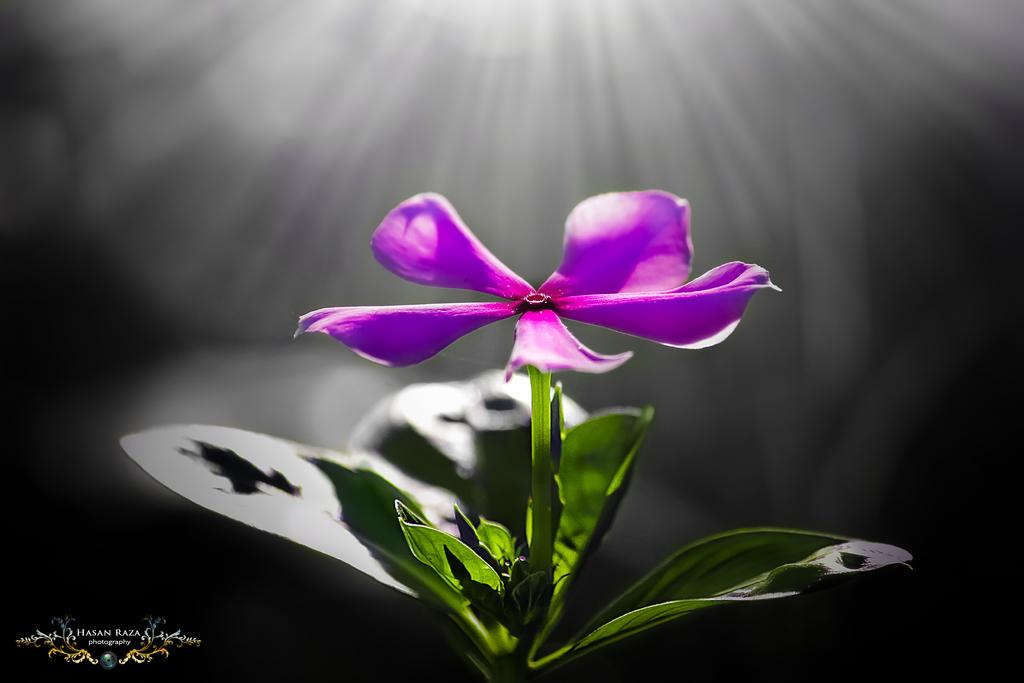What is the main subject of the image? The main subject of the image is a flower. Can you describe the flower's location in the image? The flower is on the stem of a plant. How many horses are visible in the image? There are no horses present in the image; it features a flower on the stem of a plant. What type of watch is being worn by the flower in the image? There is no watch present in the image, as it features a flower on the stem of a plant. 